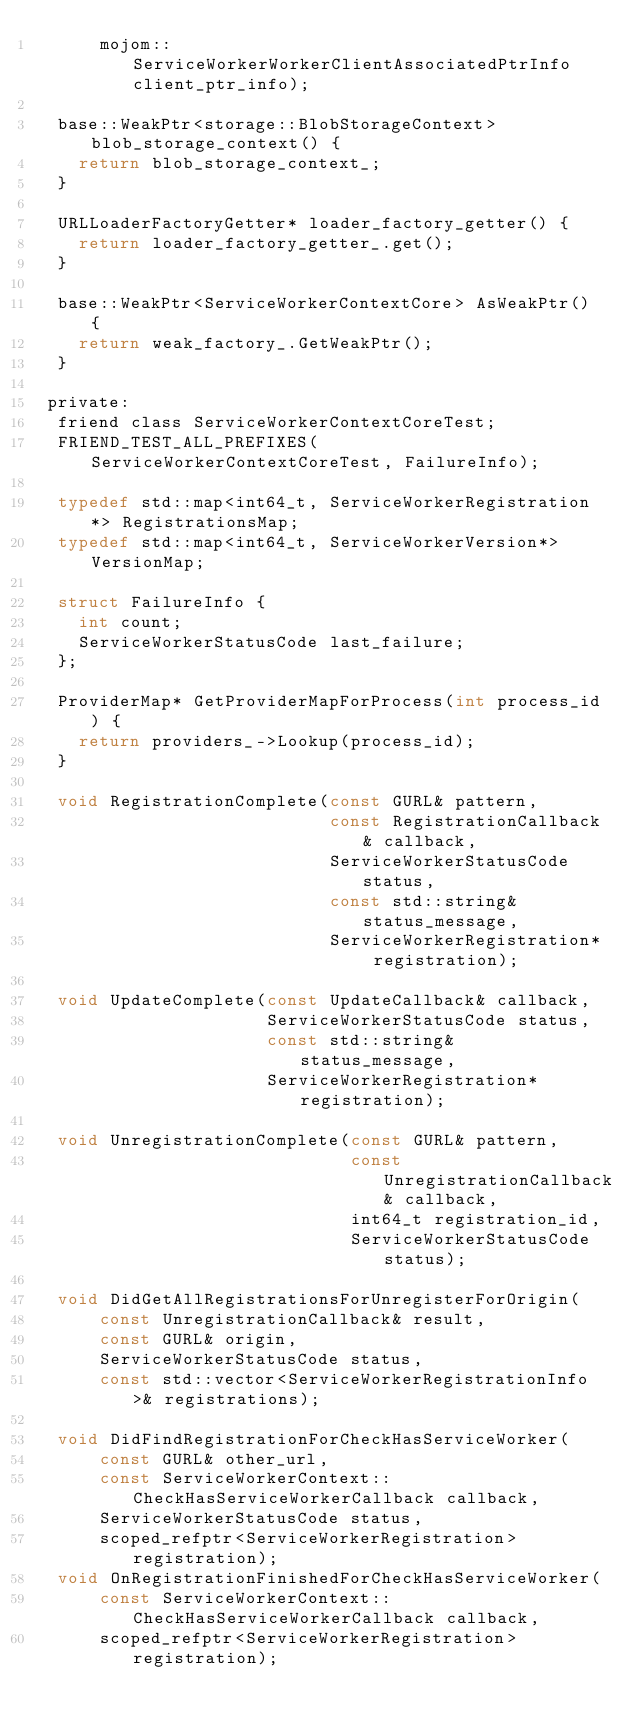<code> <loc_0><loc_0><loc_500><loc_500><_C_>      mojom::ServiceWorkerWorkerClientAssociatedPtrInfo client_ptr_info);

  base::WeakPtr<storage::BlobStorageContext> blob_storage_context() {
    return blob_storage_context_;
  }

  URLLoaderFactoryGetter* loader_factory_getter() {
    return loader_factory_getter_.get();
  }

  base::WeakPtr<ServiceWorkerContextCore> AsWeakPtr() {
    return weak_factory_.GetWeakPtr();
  }

 private:
  friend class ServiceWorkerContextCoreTest;
  FRIEND_TEST_ALL_PREFIXES(ServiceWorkerContextCoreTest, FailureInfo);

  typedef std::map<int64_t, ServiceWorkerRegistration*> RegistrationsMap;
  typedef std::map<int64_t, ServiceWorkerVersion*> VersionMap;

  struct FailureInfo {
    int count;
    ServiceWorkerStatusCode last_failure;
  };

  ProviderMap* GetProviderMapForProcess(int process_id) {
    return providers_->Lookup(process_id);
  }

  void RegistrationComplete(const GURL& pattern,
                            const RegistrationCallback& callback,
                            ServiceWorkerStatusCode status,
                            const std::string& status_message,
                            ServiceWorkerRegistration* registration);

  void UpdateComplete(const UpdateCallback& callback,
                      ServiceWorkerStatusCode status,
                      const std::string& status_message,
                      ServiceWorkerRegistration* registration);

  void UnregistrationComplete(const GURL& pattern,
                              const UnregistrationCallback& callback,
                              int64_t registration_id,
                              ServiceWorkerStatusCode status);

  void DidGetAllRegistrationsForUnregisterForOrigin(
      const UnregistrationCallback& result,
      const GURL& origin,
      ServiceWorkerStatusCode status,
      const std::vector<ServiceWorkerRegistrationInfo>& registrations);

  void DidFindRegistrationForCheckHasServiceWorker(
      const GURL& other_url,
      const ServiceWorkerContext::CheckHasServiceWorkerCallback callback,
      ServiceWorkerStatusCode status,
      scoped_refptr<ServiceWorkerRegistration> registration);
  void OnRegistrationFinishedForCheckHasServiceWorker(
      const ServiceWorkerContext::CheckHasServiceWorkerCallback callback,
      scoped_refptr<ServiceWorkerRegistration> registration);
</code> 